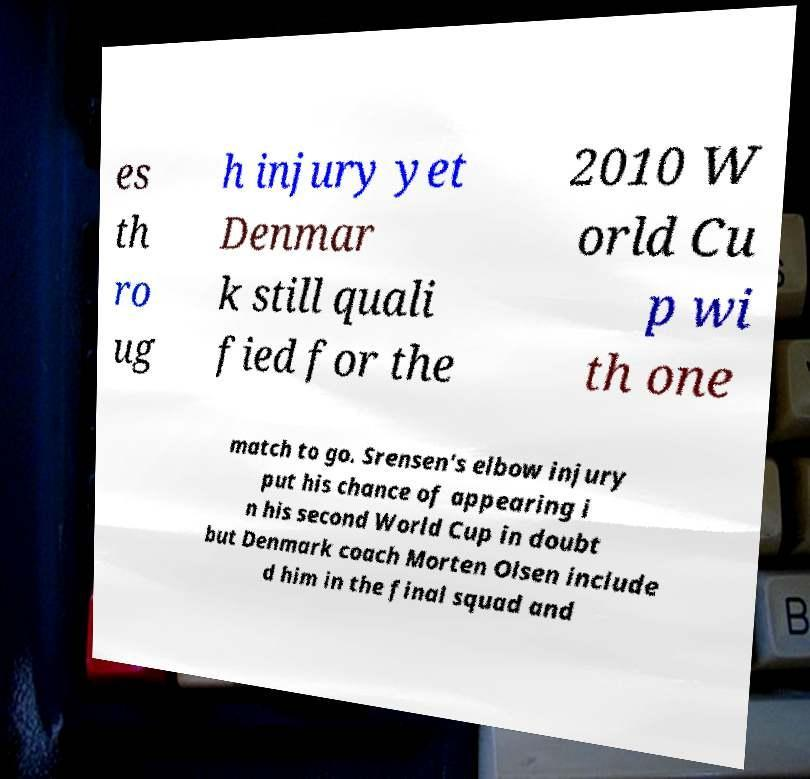Please read and relay the text visible in this image. What does it say? es th ro ug h injury yet Denmar k still quali fied for the 2010 W orld Cu p wi th one match to go. Srensen's elbow injury put his chance of appearing i n his second World Cup in doubt but Denmark coach Morten Olsen include d him in the final squad and 